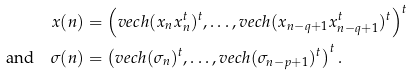<formula> <loc_0><loc_0><loc_500><loc_500>x ( n ) & = \left ( v e c h ( x _ { n } x _ { n } ^ { t } ) ^ { t } , \dots , v e c h ( x _ { n - q + 1 } x _ { n - q + 1 } ^ { t } ) ^ { t } \right ) ^ { t } \\ \text {and} \quad \sigma ( n ) & = \left ( v e c h ( \sigma _ { n } ) ^ { t } , \dots , v e c h ( \sigma _ { n - p + 1 } ) ^ { t } \right ) ^ { t } .</formula> 